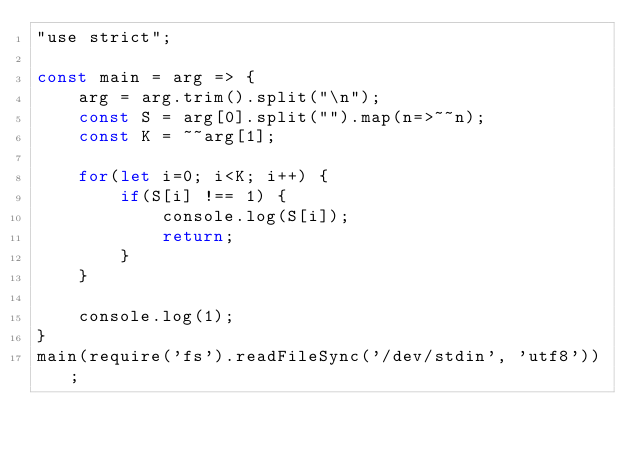<code> <loc_0><loc_0><loc_500><loc_500><_JavaScript_>"use strict";
    
const main = arg => {
    arg = arg.trim().split("\n");
    const S = arg[0].split("").map(n=>~~n);
    const K = ~~arg[1];
    
    for(let i=0; i<K; i++) {
        if(S[i] !== 1) {
            console.log(S[i]);
            return;
        }
    }
    
    console.log(1);
}
main(require('fs').readFileSync('/dev/stdin', 'utf8'));</code> 